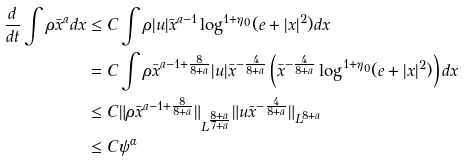Convert formula to latex. <formula><loc_0><loc_0><loc_500><loc_500>\frac { d } { d t } \int \rho \bar { x } ^ { a } d x & \leq C \int \rho | u | \bar { x } ^ { a - 1 } \log ^ { 1 + \eta _ { 0 } } ( e + | x | ^ { 2 } ) d x \\ & = C \int \rho \bar { x } ^ { a - 1 + \frac { 8 } { 8 + a } } | u | \bar { x } ^ { - \frac { 4 } { 8 + a } } \left ( \bar { x } ^ { - \frac { 4 } { 8 + a } } \log ^ { 1 + \eta _ { 0 } } ( e + | x | ^ { 2 } ) \right ) d x \\ & \leq C \| \rho \bar { x } ^ { a - 1 + \frac { 8 } { 8 + a } } \| _ { L ^ { \frac { 8 + a } { 7 + a } } } \| u \bar { x } ^ { - \frac { 4 } { 8 + a } } \| _ { L ^ { 8 + a } } \\ & \leq C \psi ^ { \alpha }</formula> 